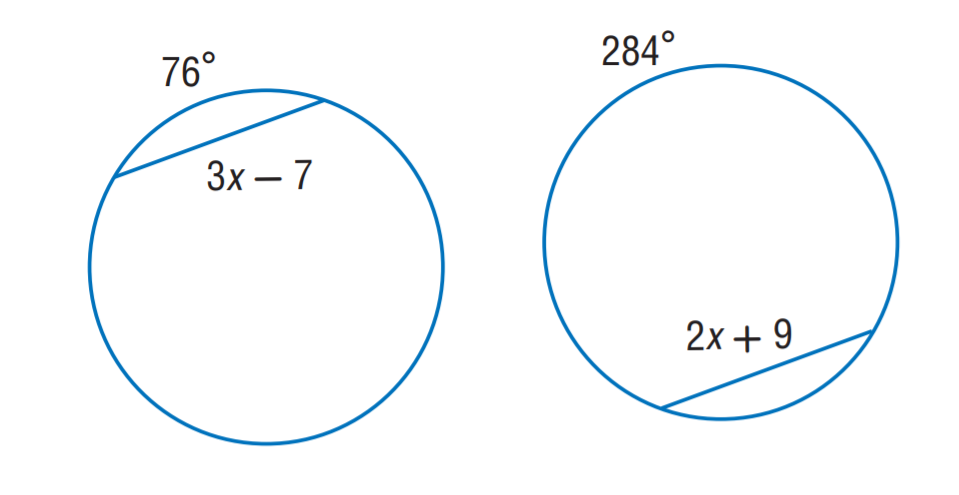Question: The two circles are congruent. Find x.
Choices:
A. 9
B. 16
C. 31
D. 41
Answer with the letter. Answer: B 